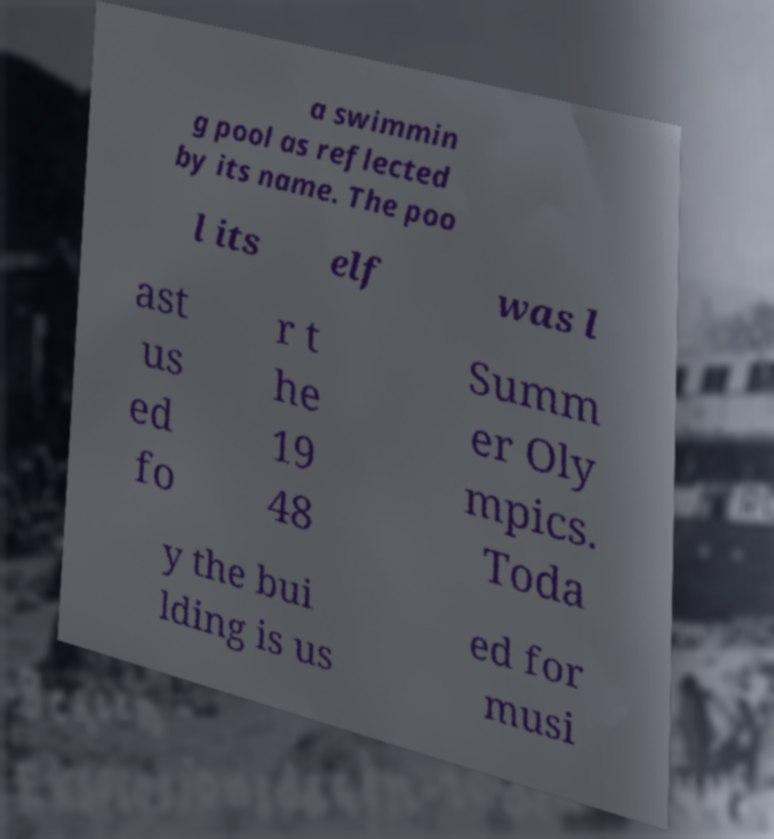There's text embedded in this image that I need extracted. Can you transcribe it verbatim? a swimmin g pool as reflected by its name. The poo l its elf was l ast us ed fo r t he 19 48 Summ er Oly mpics. Toda y the bui lding is us ed for musi 